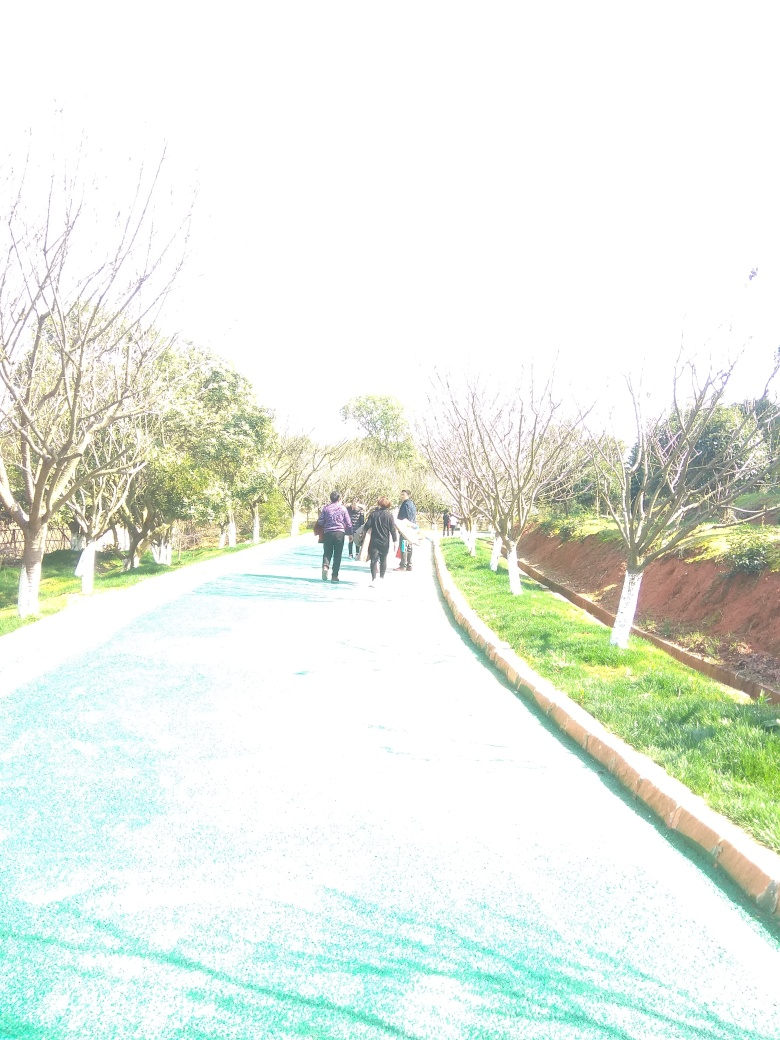What is the impact of the overexposure on the image quality?
A. Adds more details.
B. Improves the image clarity.
C. Some content is lost.
Answer with the option's letter from the given choices directly.
 C. 